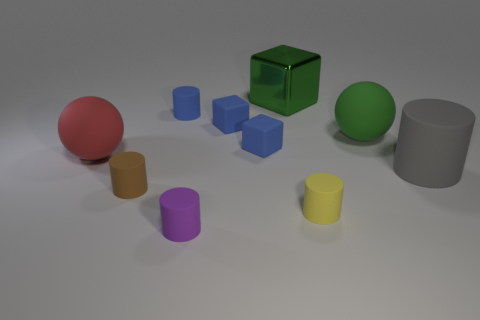Subtract all big cylinders. How many cylinders are left? 4 Subtract all blue cylinders. How many cylinders are left? 4 Subtract 1 cylinders. How many cylinders are left? 4 Subtract all green cylinders. Subtract all cyan balls. How many cylinders are left? 5 Subtract all blocks. How many objects are left? 7 Add 8 large green matte cylinders. How many large green matte cylinders exist? 8 Subtract 0 green cylinders. How many objects are left? 10 Subtract all large gray rubber objects. Subtract all tiny blue matte things. How many objects are left? 6 Add 5 green metallic things. How many green metallic things are left? 6 